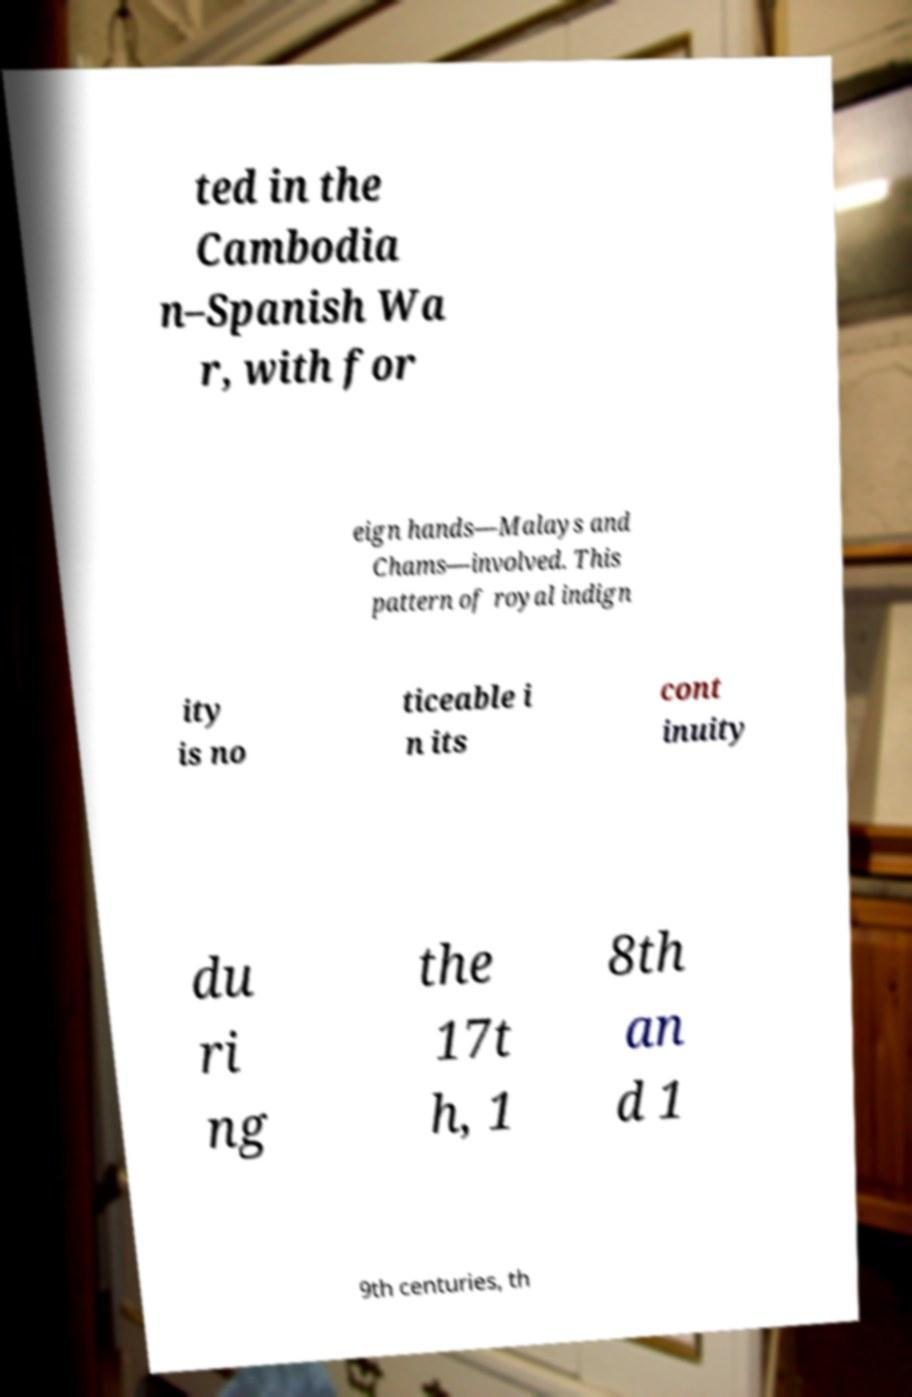There's text embedded in this image that I need extracted. Can you transcribe it verbatim? ted in the Cambodia n–Spanish Wa r, with for eign hands—Malays and Chams—involved. This pattern of royal indign ity is no ticeable i n its cont inuity du ri ng the 17t h, 1 8th an d 1 9th centuries, th 